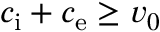<formula> <loc_0><loc_0><loc_500><loc_500>c _ { i } + c _ { e } \geq v _ { 0 }</formula> 